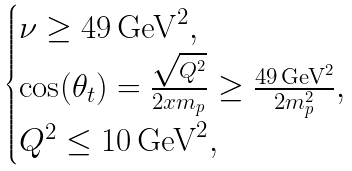Convert formula to latex. <formula><loc_0><loc_0><loc_500><loc_500>\begin{cases} \nu \geq 4 9 \, \text {GeV} ^ { 2 } , \\ \cos ( \theta _ { t } ) = \frac { \sqrt { Q ^ { 2 } } } { 2 x m _ { p } } \geq \frac { 4 9 \, \text {GeV} ^ { 2 } } { 2 m _ { p } ^ { 2 } } , \\ Q ^ { 2 } \leq 1 0 \, \text {GeV} ^ { 2 } , \end{cases}</formula> 